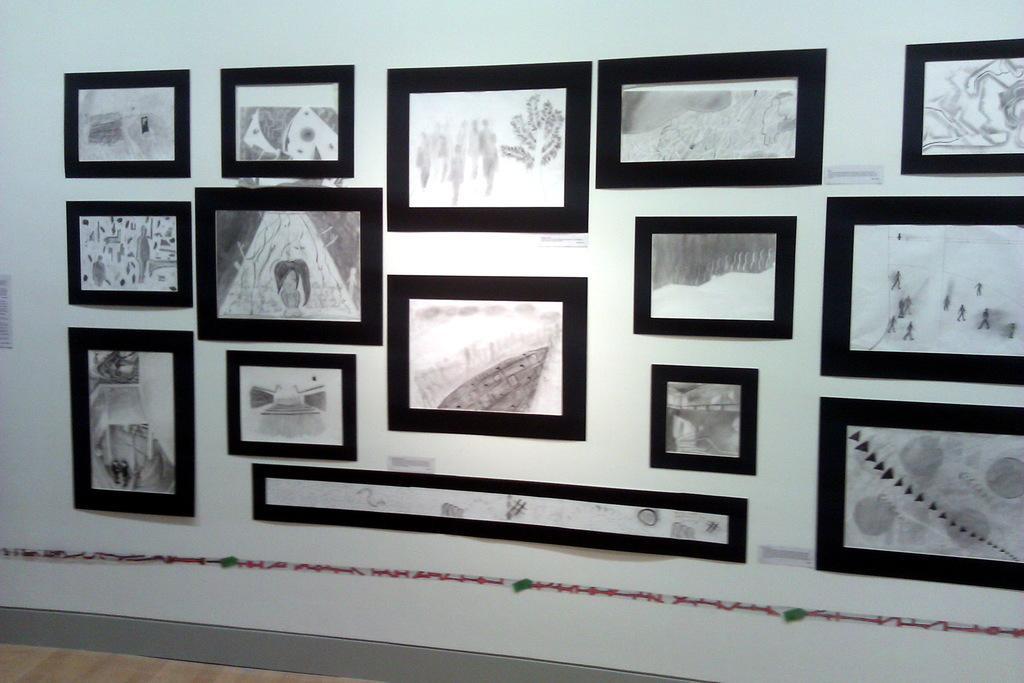Can you describe this image briefly? This picture might be taken inside the room. In this image, we can see a wall, on which some photo frames are attached to it. 